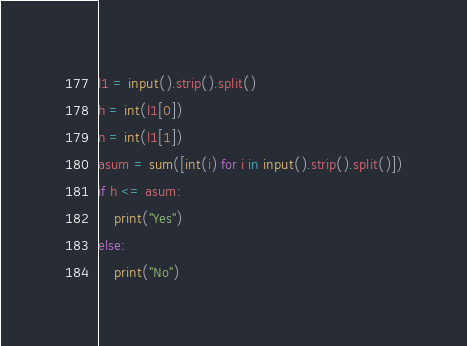Convert code to text. <code><loc_0><loc_0><loc_500><loc_500><_Python_>l1 = input().strip().split()
h = int(l1[0])
n = int(l1[1])
asum = sum([int(i) for i in input().strip().split()])
if h <= asum:
    print("Yes")
else:
    print("No")
</code> 